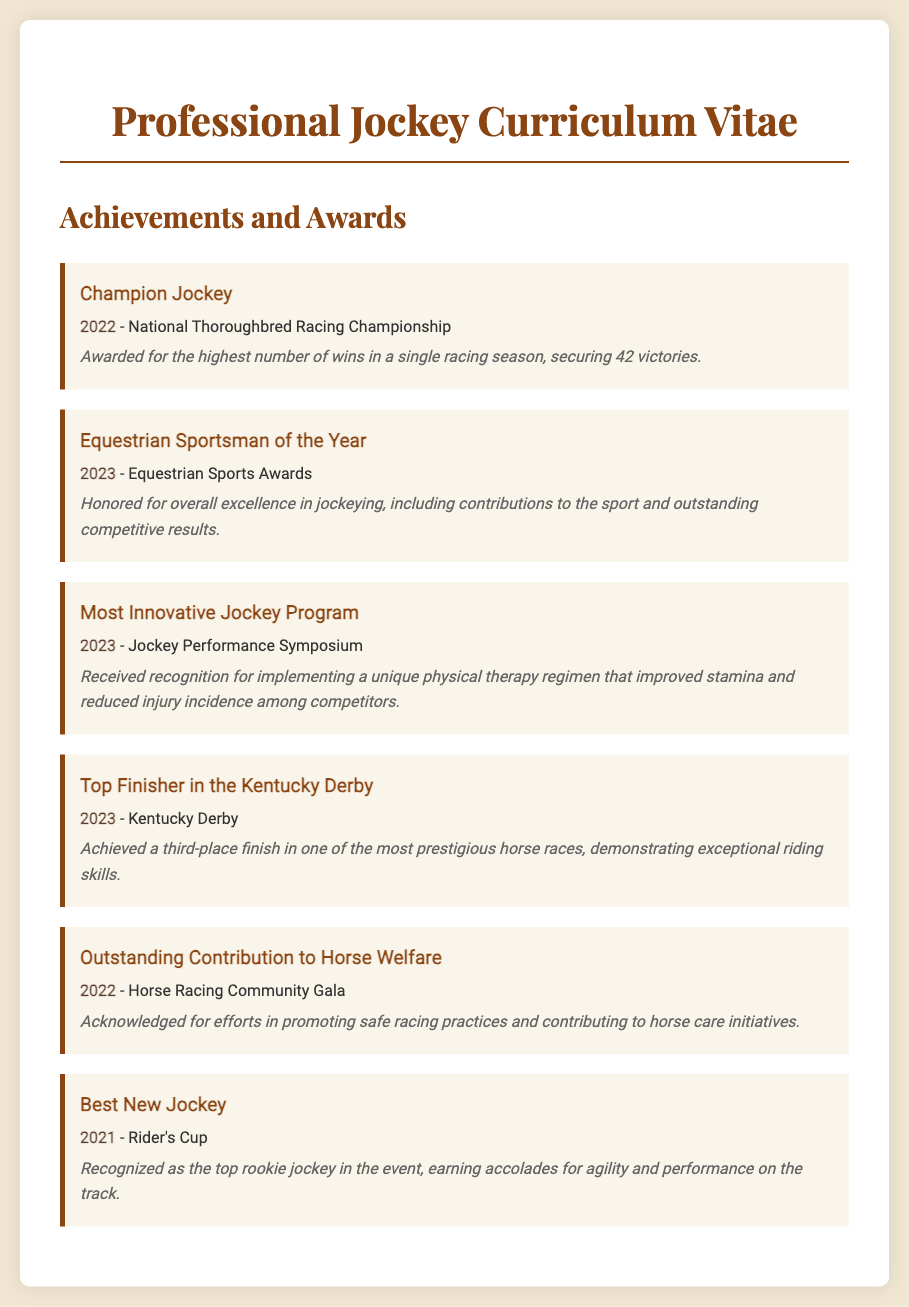What was awarded in 2022? The 2022 achievement recognized was "Champion Jockey" awarded at the National Thoroughbred Racing Championship.
Answer: Champion Jockey How many victories were secured in 2022? The achievement of "Champion Jockey" was awarded for securing 42 victories in 2022.
Answer: 42 What award did the jockey receive in 2023 for physical therapy? The recognition received in 2023 for implementing a unique physical therapy regimen was "Most Innovative Jockey Program."
Answer: Most Innovative Jockey Program In which racing event did the jockey finish third in 2023? The achievement in 2023 as a top finisher was at the Kentucky Derby, where the jockey finished third.
Answer: Kentucky Derby What year was the "Best New Jockey" award received? The "Best New Jockey" award was received in 2021 during the Rider's Cup event.
Answer: 2021 Which recognition focused on horse welfare? The achievement related to horse welfare recognized was "Outstanding Contribution to Horse Welfare" received in 2022.
Answer: Outstanding Contribution to Horse Welfare What is the name of the award received in 2023 for overall excellence? The award received for overall excellence in jockeying in 2023 is "Equestrian Sportsman of the Year."
Answer: Equestrian Sportsman of the Year What was a significant achievement in 2023 alongside sportsmanship? Achieving a significant third-place finish in the Kentucky Derby was a notable achievement alongside being named Equestrian Sportsman of the Year in 2023.
Answer: Third-place finish in the Kentucky Derby What does the "Equestrian Sports Awards" focus on? The Equestrian Sports Awards focus on overall excellence in jockeying.
Answer: Overall excellence in jockeying 